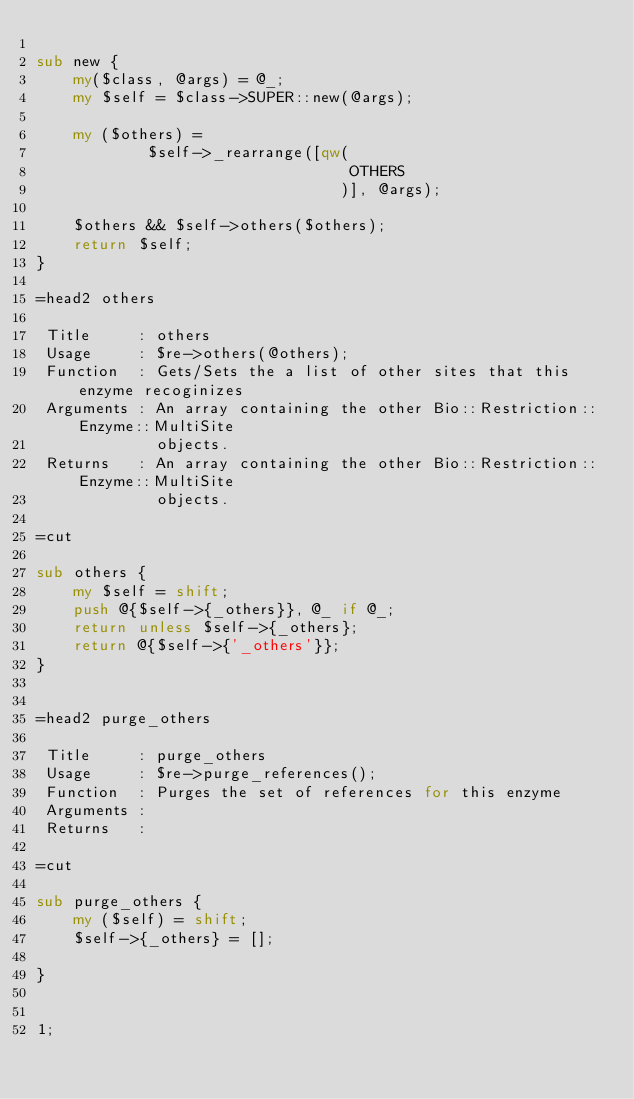<code> <loc_0><loc_0><loc_500><loc_500><_Perl_>
sub new {
    my($class, @args) = @_;
    my $self = $class->SUPER::new(@args);

    my ($others) =
            $self->_rearrange([qw(
                                  OTHERS
                                 )], @args);

    $others && $self->others($others);
    return $self;
}

=head2 others

 Title     : others
 Usage     : $re->others(@others);
 Function  : Gets/Sets the a list of other sites that this enzyme recoginizes
 Arguments : An array containing the other Bio::Restriction::Enzyme::MultiSite
             objects.
 Returns   : An array containing the other Bio::Restriction::Enzyme::MultiSite
             objects.

=cut

sub others {
    my $self = shift;
    push @{$self->{_others}}, @_ if @_;
    return unless $self->{_others};
    return @{$self->{'_others'}};
}


=head2 purge_others

 Title     : purge_others
 Usage     : $re->purge_references();
 Function  : Purges the set of references for this enzyme
 Arguments : 
 Returns   : 

=cut

sub purge_others {
    my ($self) = shift;
    $self->{_others} = [];

}


1;

</code> 